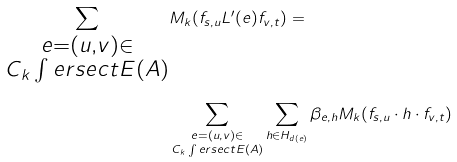Convert formula to latex. <formula><loc_0><loc_0><loc_500><loc_500>\sum _ { \substack { e = ( u , v ) \in \\ C _ { k } \int e r s e c t E ( A ) } } & M _ { k } ( f _ { s , u } L ^ { \prime } ( e ) f _ { v , t } ) = \\ & \sum _ { \substack { e = ( u , v ) \in \\ C _ { k } \int e r s e c t E ( A ) } } \sum _ { h \in H _ { d ( e ) } } \beta _ { e , h } M _ { k } ( f _ { s , u } \cdot h \cdot f _ { v , t } ) \\</formula> 